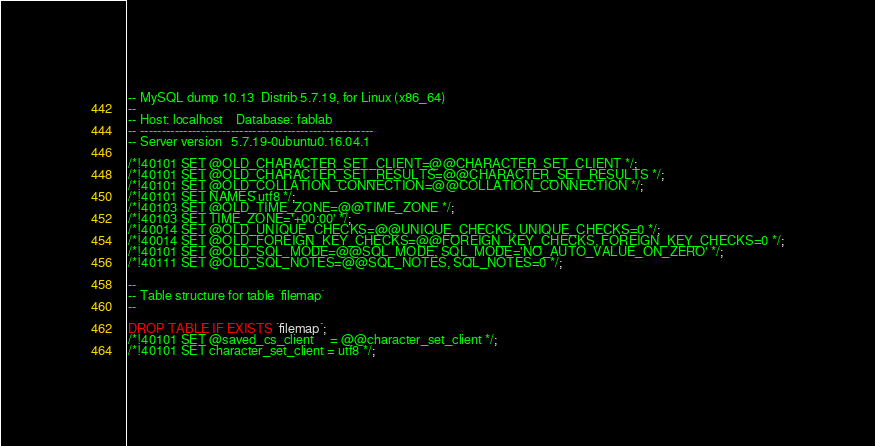Convert code to text. <code><loc_0><loc_0><loc_500><loc_500><_SQL_>-- MySQL dump 10.13  Distrib 5.7.19, for Linux (x86_64)
--
-- Host: localhost    Database: fablab
-- ------------------------------------------------------
-- Server version	5.7.19-0ubuntu0.16.04.1

/*!40101 SET @OLD_CHARACTER_SET_CLIENT=@@CHARACTER_SET_CLIENT */;
/*!40101 SET @OLD_CHARACTER_SET_RESULTS=@@CHARACTER_SET_RESULTS */;
/*!40101 SET @OLD_COLLATION_CONNECTION=@@COLLATION_CONNECTION */;
/*!40101 SET NAMES utf8 */;
/*!40103 SET @OLD_TIME_ZONE=@@TIME_ZONE */;
/*!40103 SET TIME_ZONE='+00:00' */;
/*!40014 SET @OLD_UNIQUE_CHECKS=@@UNIQUE_CHECKS, UNIQUE_CHECKS=0 */;
/*!40014 SET @OLD_FOREIGN_KEY_CHECKS=@@FOREIGN_KEY_CHECKS, FOREIGN_KEY_CHECKS=0 */;
/*!40101 SET @OLD_SQL_MODE=@@SQL_MODE, SQL_MODE='NO_AUTO_VALUE_ON_ZERO' */;
/*!40111 SET @OLD_SQL_NOTES=@@SQL_NOTES, SQL_NOTES=0 */;

--
-- Table structure for table `filemap`
--

DROP TABLE IF EXISTS `filemap`;
/*!40101 SET @saved_cs_client     = @@character_set_client */;
/*!40101 SET character_set_client = utf8 */;</code> 